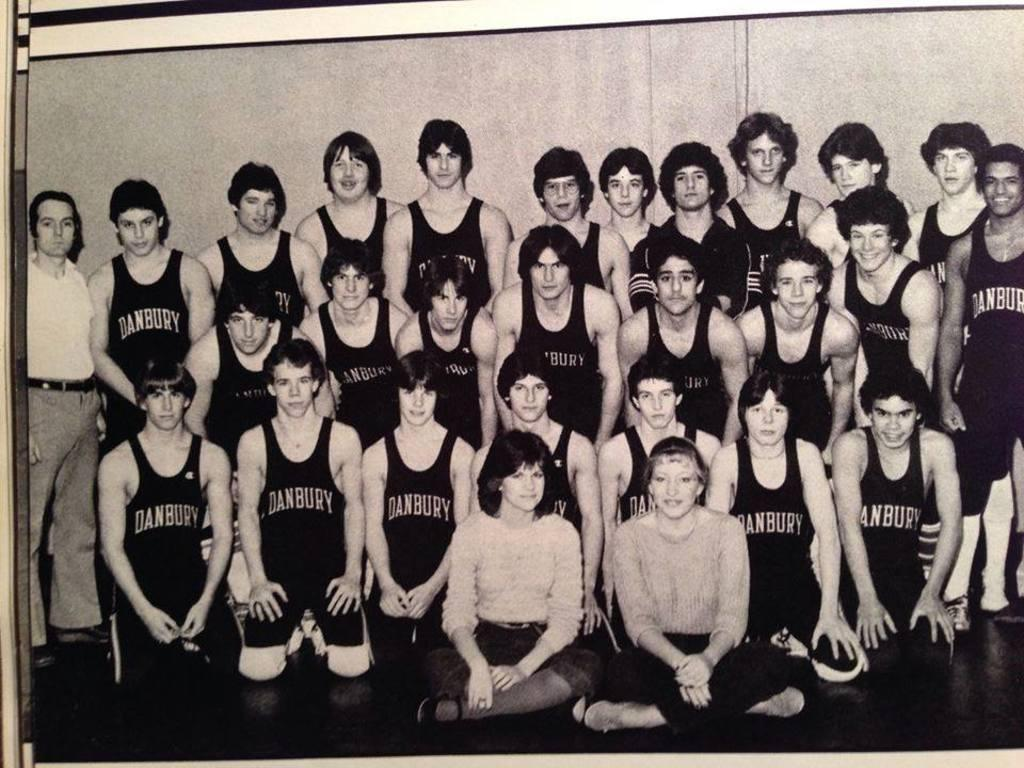<image>
Provide a brief description of the given image. A black and white photo of Danbury wrestlers posed for a group picture. 